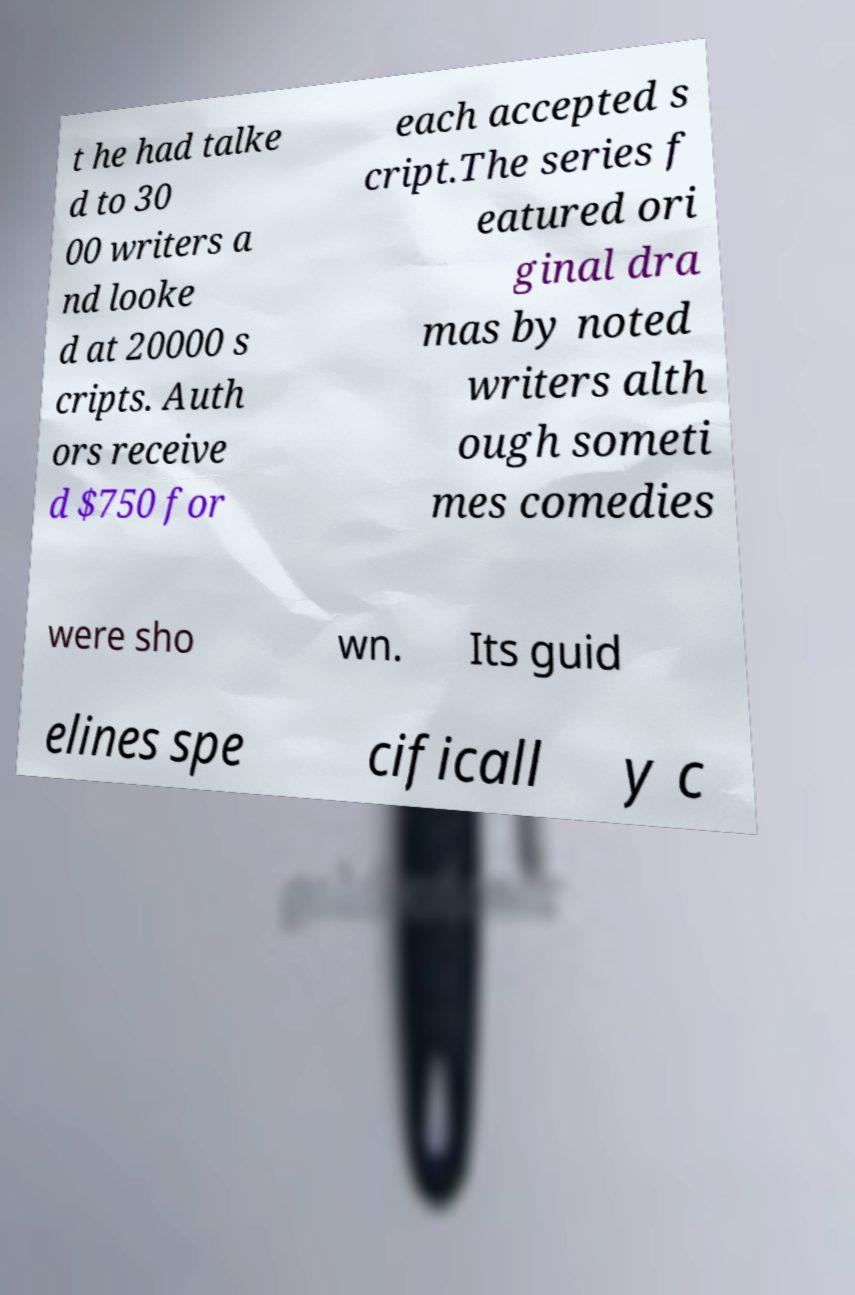Could you extract and type out the text from this image? t he had talke d to 30 00 writers a nd looke d at 20000 s cripts. Auth ors receive d $750 for each accepted s cript.The series f eatured ori ginal dra mas by noted writers alth ough someti mes comedies were sho wn. Its guid elines spe cificall y c 